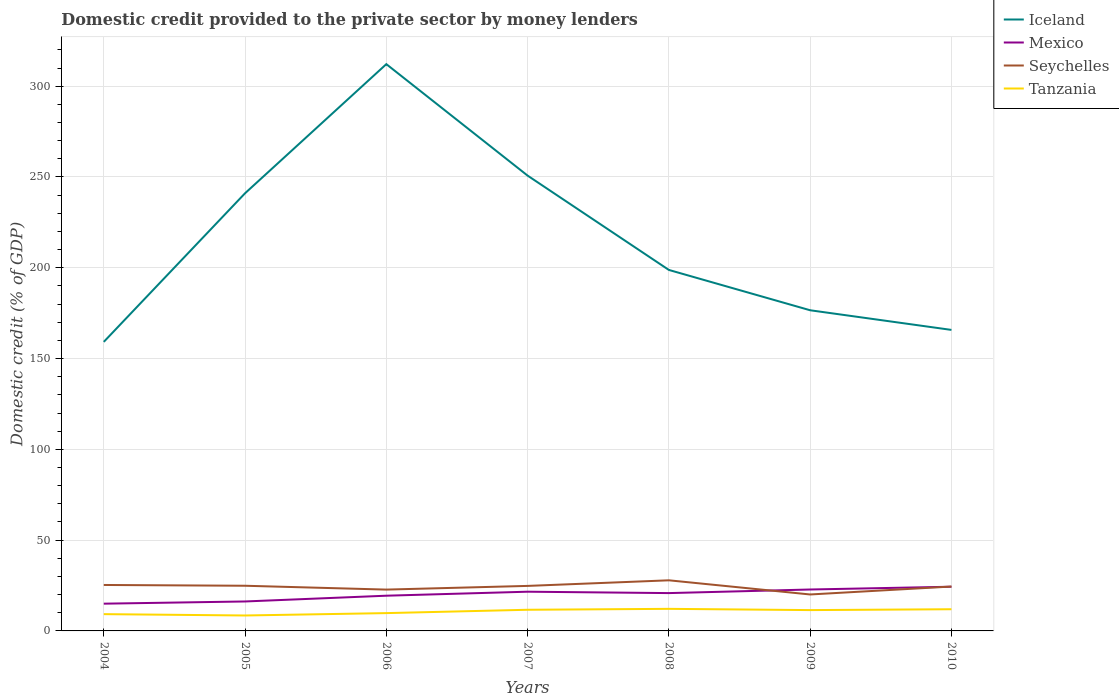How many different coloured lines are there?
Make the answer very short. 4. Is the number of lines equal to the number of legend labels?
Make the answer very short. Yes. Across all years, what is the maximum domestic credit provided to the private sector by money lenders in Tanzania?
Ensure brevity in your answer.  8.5. In which year was the domestic credit provided to the private sector by money lenders in Seychelles maximum?
Make the answer very short. 2009. What is the total domestic credit provided to the private sector by money lenders in Tanzania in the graph?
Your answer should be compact. -2.92. What is the difference between the highest and the second highest domestic credit provided to the private sector by money lenders in Tanzania?
Your answer should be very brief. 3.66. What is the difference between the highest and the lowest domestic credit provided to the private sector by money lenders in Iceland?
Your response must be concise. 3. Is the domestic credit provided to the private sector by money lenders in Iceland strictly greater than the domestic credit provided to the private sector by money lenders in Mexico over the years?
Make the answer very short. No. How many years are there in the graph?
Provide a short and direct response. 7. Are the values on the major ticks of Y-axis written in scientific E-notation?
Provide a succinct answer. No. Does the graph contain grids?
Provide a short and direct response. Yes. Where does the legend appear in the graph?
Provide a short and direct response. Top right. How many legend labels are there?
Make the answer very short. 4. What is the title of the graph?
Your answer should be very brief. Domestic credit provided to the private sector by money lenders. Does "Turkey" appear as one of the legend labels in the graph?
Ensure brevity in your answer.  No. What is the label or title of the X-axis?
Provide a short and direct response. Years. What is the label or title of the Y-axis?
Your answer should be compact. Domestic credit (% of GDP). What is the Domestic credit (% of GDP) in Iceland in 2004?
Provide a short and direct response. 159.19. What is the Domestic credit (% of GDP) of Mexico in 2004?
Make the answer very short. 15.01. What is the Domestic credit (% of GDP) in Seychelles in 2004?
Offer a terse response. 25.31. What is the Domestic credit (% of GDP) in Tanzania in 2004?
Give a very brief answer. 9.24. What is the Domestic credit (% of GDP) of Iceland in 2005?
Make the answer very short. 241.04. What is the Domestic credit (% of GDP) in Mexico in 2005?
Your response must be concise. 16.22. What is the Domestic credit (% of GDP) in Seychelles in 2005?
Make the answer very short. 24.88. What is the Domestic credit (% of GDP) of Tanzania in 2005?
Your response must be concise. 8.5. What is the Domestic credit (% of GDP) of Iceland in 2006?
Your answer should be very brief. 312.15. What is the Domestic credit (% of GDP) in Mexico in 2006?
Provide a succinct answer. 19.4. What is the Domestic credit (% of GDP) in Seychelles in 2006?
Offer a terse response. 22.76. What is the Domestic credit (% of GDP) of Tanzania in 2006?
Offer a very short reply. 9.81. What is the Domestic credit (% of GDP) of Iceland in 2007?
Ensure brevity in your answer.  250.76. What is the Domestic credit (% of GDP) in Mexico in 2007?
Give a very brief answer. 21.6. What is the Domestic credit (% of GDP) of Seychelles in 2007?
Provide a short and direct response. 24.79. What is the Domestic credit (% of GDP) of Tanzania in 2007?
Offer a very short reply. 11.65. What is the Domestic credit (% of GDP) in Iceland in 2008?
Offer a terse response. 198.81. What is the Domestic credit (% of GDP) of Mexico in 2008?
Ensure brevity in your answer.  20.84. What is the Domestic credit (% of GDP) in Seychelles in 2008?
Provide a succinct answer. 27.88. What is the Domestic credit (% of GDP) in Tanzania in 2008?
Offer a terse response. 12.16. What is the Domestic credit (% of GDP) of Iceland in 2009?
Ensure brevity in your answer.  176.6. What is the Domestic credit (% of GDP) in Mexico in 2009?
Ensure brevity in your answer.  22.81. What is the Domestic credit (% of GDP) in Seychelles in 2009?
Your answer should be compact. 20.07. What is the Domestic credit (% of GDP) in Tanzania in 2009?
Ensure brevity in your answer.  11.47. What is the Domestic credit (% of GDP) of Iceland in 2010?
Offer a terse response. 165.78. What is the Domestic credit (% of GDP) of Mexico in 2010?
Offer a very short reply. 24.34. What is the Domestic credit (% of GDP) in Seychelles in 2010?
Offer a terse response. 24.45. What is the Domestic credit (% of GDP) of Tanzania in 2010?
Provide a succinct answer. 11.94. Across all years, what is the maximum Domestic credit (% of GDP) of Iceland?
Keep it short and to the point. 312.15. Across all years, what is the maximum Domestic credit (% of GDP) of Mexico?
Your answer should be compact. 24.34. Across all years, what is the maximum Domestic credit (% of GDP) of Seychelles?
Your response must be concise. 27.88. Across all years, what is the maximum Domestic credit (% of GDP) of Tanzania?
Your answer should be very brief. 12.16. Across all years, what is the minimum Domestic credit (% of GDP) in Iceland?
Give a very brief answer. 159.19. Across all years, what is the minimum Domestic credit (% of GDP) in Mexico?
Provide a succinct answer. 15.01. Across all years, what is the minimum Domestic credit (% of GDP) of Seychelles?
Your response must be concise. 20.07. Across all years, what is the minimum Domestic credit (% of GDP) in Tanzania?
Your answer should be compact. 8.5. What is the total Domestic credit (% of GDP) in Iceland in the graph?
Your answer should be compact. 1504.34. What is the total Domestic credit (% of GDP) in Mexico in the graph?
Offer a very short reply. 140.21. What is the total Domestic credit (% of GDP) in Seychelles in the graph?
Make the answer very short. 170.14. What is the total Domestic credit (% of GDP) of Tanzania in the graph?
Offer a very short reply. 74.78. What is the difference between the Domestic credit (% of GDP) in Iceland in 2004 and that in 2005?
Provide a short and direct response. -81.85. What is the difference between the Domestic credit (% of GDP) in Mexico in 2004 and that in 2005?
Give a very brief answer. -1.21. What is the difference between the Domestic credit (% of GDP) in Seychelles in 2004 and that in 2005?
Provide a short and direct response. 0.43. What is the difference between the Domestic credit (% of GDP) in Tanzania in 2004 and that in 2005?
Your answer should be compact. 0.74. What is the difference between the Domestic credit (% of GDP) in Iceland in 2004 and that in 2006?
Make the answer very short. -152.96. What is the difference between the Domestic credit (% of GDP) of Mexico in 2004 and that in 2006?
Keep it short and to the point. -4.39. What is the difference between the Domestic credit (% of GDP) of Seychelles in 2004 and that in 2006?
Keep it short and to the point. 2.55. What is the difference between the Domestic credit (% of GDP) in Tanzania in 2004 and that in 2006?
Give a very brief answer. -0.57. What is the difference between the Domestic credit (% of GDP) of Iceland in 2004 and that in 2007?
Your answer should be very brief. -91.57. What is the difference between the Domestic credit (% of GDP) in Mexico in 2004 and that in 2007?
Your answer should be very brief. -6.59. What is the difference between the Domestic credit (% of GDP) of Seychelles in 2004 and that in 2007?
Offer a very short reply. 0.52. What is the difference between the Domestic credit (% of GDP) of Tanzania in 2004 and that in 2007?
Your answer should be compact. -2.41. What is the difference between the Domestic credit (% of GDP) of Iceland in 2004 and that in 2008?
Provide a short and direct response. -39.62. What is the difference between the Domestic credit (% of GDP) of Mexico in 2004 and that in 2008?
Give a very brief answer. -5.83. What is the difference between the Domestic credit (% of GDP) in Seychelles in 2004 and that in 2008?
Make the answer very short. -2.57. What is the difference between the Domestic credit (% of GDP) in Tanzania in 2004 and that in 2008?
Provide a succinct answer. -2.92. What is the difference between the Domestic credit (% of GDP) in Iceland in 2004 and that in 2009?
Offer a terse response. -17.41. What is the difference between the Domestic credit (% of GDP) in Mexico in 2004 and that in 2009?
Your answer should be very brief. -7.8. What is the difference between the Domestic credit (% of GDP) in Seychelles in 2004 and that in 2009?
Offer a terse response. 5.24. What is the difference between the Domestic credit (% of GDP) in Tanzania in 2004 and that in 2009?
Make the answer very short. -2.23. What is the difference between the Domestic credit (% of GDP) in Iceland in 2004 and that in 2010?
Your response must be concise. -6.59. What is the difference between the Domestic credit (% of GDP) in Mexico in 2004 and that in 2010?
Make the answer very short. -9.34. What is the difference between the Domestic credit (% of GDP) in Seychelles in 2004 and that in 2010?
Offer a very short reply. 0.87. What is the difference between the Domestic credit (% of GDP) of Tanzania in 2004 and that in 2010?
Give a very brief answer. -2.7. What is the difference between the Domestic credit (% of GDP) of Iceland in 2005 and that in 2006?
Give a very brief answer. -71.11. What is the difference between the Domestic credit (% of GDP) in Mexico in 2005 and that in 2006?
Give a very brief answer. -3.18. What is the difference between the Domestic credit (% of GDP) of Seychelles in 2005 and that in 2006?
Offer a very short reply. 2.11. What is the difference between the Domestic credit (% of GDP) of Tanzania in 2005 and that in 2006?
Keep it short and to the point. -1.31. What is the difference between the Domestic credit (% of GDP) of Iceland in 2005 and that in 2007?
Ensure brevity in your answer.  -9.72. What is the difference between the Domestic credit (% of GDP) in Mexico in 2005 and that in 2007?
Your answer should be very brief. -5.38. What is the difference between the Domestic credit (% of GDP) of Seychelles in 2005 and that in 2007?
Provide a succinct answer. 0.08. What is the difference between the Domestic credit (% of GDP) in Tanzania in 2005 and that in 2007?
Your answer should be compact. -3.15. What is the difference between the Domestic credit (% of GDP) in Iceland in 2005 and that in 2008?
Your answer should be compact. 42.24. What is the difference between the Domestic credit (% of GDP) in Mexico in 2005 and that in 2008?
Your answer should be very brief. -4.62. What is the difference between the Domestic credit (% of GDP) of Seychelles in 2005 and that in 2008?
Your answer should be very brief. -3. What is the difference between the Domestic credit (% of GDP) in Tanzania in 2005 and that in 2008?
Provide a succinct answer. -3.66. What is the difference between the Domestic credit (% of GDP) of Iceland in 2005 and that in 2009?
Keep it short and to the point. 64.44. What is the difference between the Domestic credit (% of GDP) in Mexico in 2005 and that in 2009?
Give a very brief answer. -6.59. What is the difference between the Domestic credit (% of GDP) in Seychelles in 2005 and that in 2009?
Keep it short and to the point. 4.8. What is the difference between the Domestic credit (% of GDP) in Tanzania in 2005 and that in 2009?
Offer a terse response. -2.96. What is the difference between the Domestic credit (% of GDP) of Iceland in 2005 and that in 2010?
Offer a terse response. 75.26. What is the difference between the Domestic credit (% of GDP) in Mexico in 2005 and that in 2010?
Give a very brief answer. -8.12. What is the difference between the Domestic credit (% of GDP) of Seychelles in 2005 and that in 2010?
Provide a succinct answer. 0.43. What is the difference between the Domestic credit (% of GDP) in Tanzania in 2005 and that in 2010?
Provide a succinct answer. -3.44. What is the difference between the Domestic credit (% of GDP) in Iceland in 2006 and that in 2007?
Provide a succinct answer. 61.39. What is the difference between the Domestic credit (% of GDP) of Mexico in 2006 and that in 2007?
Your answer should be very brief. -2.2. What is the difference between the Domestic credit (% of GDP) of Seychelles in 2006 and that in 2007?
Give a very brief answer. -2.03. What is the difference between the Domestic credit (% of GDP) in Tanzania in 2006 and that in 2007?
Provide a short and direct response. -1.84. What is the difference between the Domestic credit (% of GDP) of Iceland in 2006 and that in 2008?
Provide a short and direct response. 113.35. What is the difference between the Domestic credit (% of GDP) of Mexico in 2006 and that in 2008?
Make the answer very short. -1.44. What is the difference between the Domestic credit (% of GDP) in Seychelles in 2006 and that in 2008?
Keep it short and to the point. -5.11. What is the difference between the Domestic credit (% of GDP) of Tanzania in 2006 and that in 2008?
Offer a terse response. -2.35. What is the difference between the Domestic credit (% of GDP) of Iceland in 2006 and that in 2009?
Your answer should be very brief. 135.55. What is the difference between the Domestic credit (% of GDP) in Mexico in 2006 and that in 2009?
Provide a short and direct response. -3.41. What is the difference between the Domestic credit (% of GDP) of Seychelles in 2006 and that in 2009?
Make the answer very short. 2.69. What is the difference between the Domestic credit (% of GDP) in Tanzania in 2006 and that in 2009?
Offer a terse response. -1.66. What is the difference between the Domestic credit (% of GDP) of Iceland in 2006 and that in 2010?
Make the answer very short. 146.37. What is the difference between the Domestic credit (% of GDP) of Mexico in 2006 and that in 2010?
Give a very brief answer. -4.95. What is the difference between the Domestic credit (% of GDP) in Seychelles in 2006 and that in 2010?
Provide a succinct answer. -1.68. What is the difference between the Domestic credit (% of GDP) in Tanzania in 2006 and that in 2010?
Give a very brief answer. -2.13. What is the difference between the Domestic credit (% of GDP) in Iceland in 2007 and that in 2008?
Ensure brevity in your answer.  51.96. What is the difference between the Domestic credit (% of GDP) in Mexico in 2007 and that in 2008?
Make the answer very short. 0.76. What is the difference between the Domestic credit (% of GDP) in Seychelles in 2007 and that in 2008?
Provide a succinct answer. -3.08. What is the difference between the Domestic credit (% of GDP) in Tanzania in 2007 and that in 2008?
Your answer should be compact. -0.51. What is the difference between the Domestic credit (% of GDP) of Iceland in 2007 and that in 2009?
Offer a terse response. 74.16. What is the difference between the Domestic credit (% of GDP) of Mexico in 2007 and that in 2009?
Make the answer very short. -1.21. What is the difference between the Domestic credit (% of GDP) of Seychelles in 2007 and that in 2009?
Ensure brevity in your answer.  4.72. What is the difference between the Domestic credit (% of GDP) in Tanzania in 2007 and that in 2009?
Keep it short and to the point. 0.18. What is the difference between the Domestic credit (% of GDP) of Iceland in 2007 and that in 2010?
Give a very brief answer. 84.98. What is the difference between the Domestic credit (% of GDP) in Mexico in 2007 and that in 2010?
Offer a terse response. -2.74. What is the difference between the Domestic credit (% of GDP) of Seychelles in 2007 and that in 2010?
Offer a terse response. 0.35. What is the difference between the Domestic credit (% of GDP) of Tanzania in 2007 and that in 2010?
Keep it short and to the point. -0.29. What is the difference between the Domestic credit (% of GDP) in Iceland in 2008 and that in 2009?
Offer a very short reply. 22.2. What is the difference between the Domestic credit (% of GDP) in Mexico in 2008 and that in 2009?
Your answer should be compact. -1.97. What is the difference between the Domestic credit (% of GDP) of Seychelles in 2008 and that in 2009?
Offer a terse response. 7.8. What is the difference between the Domestic credit (% of GDP) in Tanzania in 2008 and that in 2009?
Provide a succinct answer. 0.69. What is the difference between the Domestic credit (% of GDP) of Iceland in 2008 and that in 2010?
Provide a short and direct response. 33.02. What is the difference between the Domestic credit (% of GDP) of Mexico in 2008 and that in 2010?
Offer a very short reply. -3.51. What is the difference between the Domestic credit (% of GDP) of Seychelles in 2008 and that in 2010?
Offer a very short reply. 3.43. What is the difference between the Domestic credit (% of GDP) in Tanzania in 2008 and that in 2010?
Your answer should be very brief. 0.22. What is the difference between the Domestic credit (% of GDP) of Iceland in 2009 and that in 2010?
Ensure brevity in your answer.  10.82. What is the difference between the Domestic credit (% of GDP) in Mexico in 2009 and that in 2010?
Provide a short and direct response. -1.53. What is the difference between the Domestic credit (% of GDP) in Seychelles in 2009 and that in 2010?
Offer a very short reply. -4.37. What is the difference between the Domestic credit (% of GDP) of Tanzania in 2009 and that in 2010?
Provide a succinct answer. -0.48. What is the difference between the Domestic credit (% of GDP) of Iceland in 2004 and the Domestic credit (% of GDP) of Mexico in 2005?
Your answer should be very brief. 142.97. What is the difference between the Domestic credit (% of GDP) of Iceland in 2004 and the Domestic credit (% of GDP) of Seychelles in 2005?
Provide a short and direct response. 134.31. What is the difference between the Domestic credit (% of GDP) of Iceland in 2004 and the Domestic credit (% of GDP) of Tanzania in 2005?
Make the answer very short. 150.69. What is the difference between the Domestic credit (% of GDP) of Mexico in 2004 and the Domestic credit (% of GDP) of Seychelles in 2005?
Your answer should be very brief. -9.87. What is the difference between the Domestic credit (% of GDP) in Mexico in 2004 and the Domestic credit (% of GDP) in Tanzania in 2005?
Offer a very short reply. 6.5. What is the difference between the Domestic credit (% of GDP) of Seychelles in 2004 and the Domestic credit (% of GDP) of Tanzania in 2005?
Offer a very short reply. 16.81. What is the difference between the Domestic credit (% of GDP) in Iceland in 2004 and the Domestic credit (% of GDP) in Mexico in 2006?
Give a very brief answer. 139.79. What is the difference between the Domestic credit (% of GDP) of Iceland in 2004 and the Domestic credit (% of GDP) of Seychelles in 2006?
Your answer should be compact. 136.42. What is the difference between the Domestic credit (% of GDP) in Iceland in 2004 and the Domestic credit (% of GDP) in Tanzania in 2006?
Give a very brief answer. 149.38. What is the difference between the Domestic credit (% of GDP) of Mexico in 2004 and the Domestic credit (% of GDP) of Seychelles in 2006?
Offer a very short reply. -7.76. What is the difference between the Domestic credit (% of GDP) of Mexico in 2004 and the Domestic credit (% of GDP) of Tanzania in 2006?
Your answer should be compact. 5.2. What is the difference between the Domestic credit (% of GDP) in Seychelles in 2004 and the Domestic credit (% of GDP) in Tanzania in 2006?
Ensure brevity in your answer.  15.5. What is the difference between the Domestic credit (% of GDP) of Iceland in 2004 and the Domestic credit (% of GDP) of Mexico in 2007?
Your answer should be compact. 137.59. What is the difference between the Domestic credit (% of GDP) of Iceland in 2004 and the Domestic credit (% of GDP) of Seychelles in 2007?
Offer a very short reply. 134.4. What is the difference between the Domestic credit (% of GDP) of Iceland in 2004 and the Domestic credit (% of GDP) of Tanzania in 2007?
Your response must be concise. 147.54. What is the difference between the Domestic credit (% of GDP) in Mexico in 2004 and the Domestic credit (% of GDP) in Seychelles in 2007?
Make the answer very short. -9.79. What is the difference between the Domestic credit (% of GDP) of Mexico in 2004 and the Domestic credit (% of GDP) of Tanzania in 2007?
Ensure brevity in your answer.  3.35. What is the difference between the Domestic credit (% of GDP) of Seychelles in 2004 and the Domestic credit (% of GDP) of Tanzania in 2007?
Make the answer very short. 13.66. What is the difference between the Domestic credit (% of GDP) in Iceland in 2004 and the Domestic credit (% of GDP) in Mexico in 2008?
Give a very brief answer. 138.35. What is the difference between the Domestic credit (% of GDP) in Iceland in 2004 and the Domestic credit (% of GDP) in Seychelles in 2008?
Your answer should be compact. 131.31. What is the difference between the Domestic credit (% of GDP) in Iceland in 2004 and the Domestic credit (% of GDP) in Tanzania in 2008?
Your answer should be very brief. 147.03. What is the difference between the Domestic credit (% of GDP) of Mexico in 2004 and the Domestic credit (% of GDP) of Seychelles in 2008?
Offer a very short reply. -12.87. What is the difference between the Domestic credit (% of GDP) of Mexico in 2004 and the Domestic credit (% of GDP) of Tanzania in 2008?
Give a very brief answer. 2.85. What is the difference between the Domestic credit (% of GDP) of Seychelles in 2004 and the Domestic credit (% of GDP) of Tanzania in 2008?
Your response must be concise. 13.15. What is the difference between the Domestic credit (% of GDP) in Iceland in 2004 and the Domestic credit (% of GDP) in Mexico in 2009?
Give a very brief answer. 136.38. What is the difference between the Domestic credit (% of GDP) of Iceland in 2004 and the Domestic credit (% of GDP) of Seychelles in 2009?
Provide a succinct answer. 139.12. What is the difference between the Domestic credit (% of GDP) in Iceland in 2004 and the Domestic credit (% of GDP) in Tanzania in 2009?
Keep it short and to the point. 147.72. What is the difference between the Domestic credit (% of GDP) in Mexico in 2004 and the Domestic credit (% of GDP) in Seychelles in 2009?
Offer a terse response. -5.07. What is the difference between the Domestic credit (% of GDP) in Mexico in 2004 and the Domestic credit (% of GDP) in Tanzania in 2009?
Offer a terse response. 3.54. What is the difference between the Domestic credit (% of GDP) in Seychelles in 2004 and the Domestic credit (% of GDP) in Tanzania in 2009?
Provide a succinct answer. 13.84. What is the difference between the Domestic credit (% of GDP) of Iceland in 2004 and the Domestic credit (% of GDP) of Mexico in 2010?
Your response must be concise. 134.85. What is the difference between the Domestic credit (% of GDP) in Iceland in 2004 and the Domestic credit (% of GDP) in Seychelles in 2010?
Make the answer very short. 134.74. What is the difference between the Domestic credit (% of GDP) in Iceland in 2004 and the Domestic credit (% of GDP) in Tanzania in 2010?
Your answer should be very brief. 147.25. What is the difference between the Domestic credit (% of GDP) of Mexico in 2004 and the Domestic credit (% of GDP) of Seychelles in 2010?
Provide a succinct answer. -9.44. What is the difference between the Domestic credit (% of GDP) of Mexico in 2004 and the Domestic credit (% of GDP) of Tanzania in 2010?
Your answer should be very brief. 3.06. What is the difference between the Domestic credit (% of GDP) of Seychelles in 2004 and the Domestic credit (% of GDP) of Tanzania in 2010?
Your response must be concise. 13.37. What is the difference between the Domestic credit (% of GDP) of Iceland in 2005 and the Domestic credit (% of GDP) of Mexico in 2006?
Provide a short and direct response. 221.65. What is the difference between the Domestic credit (% of GDP) of Iceland in 2005 and the Domestic credit (% of GDP) of Seychelles in 2006?
Offer a terse response. 218.28. What is the difference between the Domestic credit (% of GDP) of Iceland in 2005 and the Domestic credit (% of GDP) of Tanzania in 2006?
Offer a terse response. 231.23. What is the difference between the Domestic credit (% of GDP) in Mexico in 2005 and the Domestic credit (% of GDP) in Seychelles in 2006?
Offer a terse response. -6.55. What is the difference between the Domestic credit (% of GDP) in Mexico in 2005 and the Domestic credit (% of GDP) in Tanzania in 2006?
Your response must be concise. 6.41. What is the difference between the Domestic credit (% of GDP) of Seychelles in 2005 and the Domestic credit (% of GDP) of Tanzania in 2006?
Keep it short and to the point. 15.06. What is the difference between the Domestic credit (% of GDP) of Iceland in 2005 and the Domestic credit (% of GDP) of Mexico in 2007?
Your answer should be compact. 219.44. What is the difference between the Domestic credit (% of GDP) of Iceland in 2005 and the Domestic credit (% of GDP) of Seychelles in 2007?
Give a very brief answer. 216.25. What is the difference between the Domestic credit (% of GDP) of Iceland in 2005 and the Domestic credit (% of GDP) of Tanzania in 2007?
Ensure brevity in your answer.  229.39. What is the difference between the Domestic credit (% of GDP) in Mexico in 2005 and the Domestic credit (% of GDP) in Seychelles in 2007?
Offer a very short reply. -8.58. What is the difference between the Domestic credit (% of GDP) in Mexico in 2005 and the Domestic credit (% of GDP) in Tanzania in 2007?
Provide a short and direct response. 4.57. What is the difference between the Domestic credit (% of GDP) of Seychelles in 2005 and the Domestic credit (% of GDP) of Tanzania in 2007?
Your answer should be very brief. 13.22. What is the difference between the Domestic credit (% of GDP) in Iceland in 2005 and the Domestic credit (% of GDP) in Mexico in 2008?
Provide a short and direct response. 220.21. What is the difference between the Domestic credit (% of GDP) of Iceland in 2005 and the Domestic credit (% of GDP) of Seychelles in 2008?
Give a very brief answer. 213.17. What is the difference between the Domestic credit (% of GDP) in Iceland in 2005 and the Domestic credit (% of GDP) in Tanzania in 2008?
Make the answer very short. 228.88. What is the difference between the Domestic credit (% of GDP) of Mexico in 2005 and the Domestic credit (% of GDP) of Seychelles in 2008?
Provide a succinct answer. -11.66. What is the difference between the Domestic credit (% of GDP) of Mexico in 2005 and the Domestic credit (% of GDP) of Tanzania in 2008?
Give a very brief answer. 4.06. What is the difference between the Domestic credit (% of GDP) in Seychelles in 2005 and the Domestic credit (% of GDP) in Tanzania in 2008?
Your response must be concise. 12.72. What is the difference between the Domestic credit (% of GDP) of Iceland in 2005 and the Domestic credit (% of GDP) of Mexico in 2009?
Your answer should be compact. 218.23. What is the difference between the Domestic credit (% of GDP) of Iceland in 2005 and the Domestic credit (% of GDP) of Seychelles in 2009?
Make the answer very short. 220.97. What is the difference between the Domestic credit (% of GDP) of Iceland in 2005 and the Domestic credit (% of GDP) of Tanzania in 2009?
Provide a short and direct response. 229.58. What is the difference between the Domestic credit (% of GDP) in Mexico in 2005 and the Domestic credit (% of GDP) in Seychelles in 2009?
Your answer should be compact. -3.85. What is the difference between the Domestic credit (% of GDP) of Mexico in 2005 and the Domestic credit (% of GDP) of Tanzania in 2009?
Ensure brevity in your answer.  4.75. What is the difference between the Domestic credit (% of GDP) of Seychelles in 2005 and the Domestic credit (% of GDP) of Tanzania in 2009?
Provide a succinct answer. 13.41. What is the difference between the Domestic credit (% of GDP) in Iceland in 2005 and the Domestic credit (% of GDP) in Mexico in 2010?
Ensure brevity in your answer.  216.7. What is the difference between the Domestic credit (% of GDP) of Iceland in 2005 and the Domestic credit (% of GDP) of Seychelles in 2010?
Provide a short and direct response. 216.6. What is the difference between the Domestic credit (% of GDP) of Iceland in 2005 and the Domestic credit (% of GDP) of Tanzania in 2010?
Make the answer very short. 229.1. What is the difference between the Domestic credit (% of GDP) in Mexico in 2005 and the Domestic credit (% of GDP) in Seychelles in 2010?
Provide a short and direct response. -8.23. What is the difference between the Domestic credit (% of GDP) of Mexico in 2005 and the Domestic credit (% of GDP) of Tanzania in 2010?
Keep it short and to the point. 4.28. What is the difference between the Domestic credit (% of GDP) of Seychelles in 2005 and the Domestic credit (% of GDP) of Tanzania in 2010?
Give a very brief answer. 12.93. What is the difference between the Domestic credit (% of GDP) of Iceland in 2006 and the Domestic credit (% of GDP) of Mexico in 2007?
Offer a very short reply. 290.55. What is the difference between the Domestic credit (% of GDP) of Iceland in 2006 and the Domestic credit (% of GDP) of Seychelles in 2007?
Your response must be concise. 287.36. What is the difference between the Domestic credit (% of GDP) in Iceland in 2006 and the Domestic credit (% of GDP) in Tanzania in 2007?
Your response must be concise. 300.5. What is the difference between the Domestic credit (% of GDP) of Mexico in 2006 and the Domestic credit (% of GDP) of Seychelles in 2007?
Keep it short and to the point. -5.4. What is the difference between the Domestic credit (% of GDP) in Mexico in 2006 and the Domestic credit (% of GDP) in Tanzania in 2007?
Provide a succinct answer. 7.75. What is the difference between the Domestic credit (% of GDP) of Seychelles in 2006 and the Domestic credit (% of GDP) of Tanzania in 2007?
Offer a terse response. 11.11. What is the difference between the Domestic credit (% of GDP) of Iceland in 2006 and the Domestic credit (% of GDP) of Mexico in 2008?
Give a very brief answer. 291.32. What is the difference between the Domestic credit (% of GDP) in Iceland in 2006 and the Domestic credit (% of GDP) in Seychelles in 2008?
Make the answer very short. 284.28. What is the difference between the Domestic credit (% of GDP) of Iceland in 2006 and the Domestic credit (% of GDP) of Tanzania in 2008?
Offer a very short reply. 299.99. What is the difference between the Domestic credit (% of GDP) in Mexico in 2006 and the Domestic credit (% of GDP) in Seychelles in 2008?
Your answer should be very brief. -8.48. What is the difference between the Domestic credit (% of GDP) of Mexico in 2006 and the Domestic credit (% of GDP) of Tanzania in 2008?
Ensure brevity in your answer.  7.24. What is the difference between the Domestic credit (% of GDP) in Seychelles in 2006 and the Domestic credit (% of GDP) in Tanzania in 2008?
Your answer should be compact. 10.6. What is the difference between the Domestic credit (% of GDP) of Iceland in 2006 and the Domestic credit (% of GDP) of Mexico in 2009?
Make the answer very short. 289.34. What is the difference between the Domestic credit (% of GDP) of Iceland in 2006 and the Domestic credit (% of GDP) of Seychelles in 2009?
Your answer should be compact. 292.08. What is the difference between the Domestic credit (% of GDP) of Iceland in 2006 and the Domestic credit (% of GDP) of Tanzania in 2009?
Offer a very short reply. 300.69. What is the difference between the Domestic credit (% of GDP) in Mexico in 2006 and the Domestic credit (% of GDP) in Seychelles in 2009?
Your answer should be very brief. -0.68. What is the difference between the Domestic credit (% of GDP) of Mexico in 2006 and the Domestic credit (% of GDP) of Tanzania in 2009?
Provide a short and direct response. 7.93. What is the difference between the Domestic credit (% of GDP) of Seychelles in 2006 and the Domestic credit (% of GDP) of Tanzania in 2009?
Ensure brevity in your answer.  11.3. What is the difference between the Domestic credit (% of GDP) of Iceland in 2006 and the Domestic credit (% of GDP) of Mexico in 2010?
Your answer should be compact. 287.81. What is the difference between the Domestic credit (% of GDP) in Iceland in 2006 and the Domestic credit (% of GDP) in Seychelles in 2010?
Provide a succinct answer. 287.71. What is the difference between the Domestic credit (% of GDP) of Iceland in 2006 and the Domestic credit (% of GDP) of Tanzania in 2010?
Offer a very short reply. 300.21. What is the difference between the Domestic credit (% of GDP) in Mexico in 2006 and the Domestic credit (% of GDP) in Seychelles in 2010?
Provide a succinct answer. -5.05. What is the difference between the Domestic credit (% of GDP) of Mexico in 2006 and the Domestic credit (% of GDP) of Tanzania in 2010?
Give a very brief answer. 7.45. What is the difference between the Domestic credit (% of GDP) in Seychelles in 2006 and the Domestic credit (% of GDP) in Tanzania in 2010?
Your response must be concise. 10.82. What is the difference between the Domestic credit (% of GDP) of Iceland in 2007 and the Domestic credit (% of GDP) of Mexico in 2008?
Your answer should be very brief. 229.93. What is the difference between the Domestic credit (% of GDP) in Iceland in 2007 and the Domestic credit (% of GDP) in Seychelles in 2008?
Offer a very short reply. 222.89. What is the difference between the Domestic credit (% of GDP) of Iceland in 2007 and the Domestic credit (% of GDP) of Tanzania in 2008?
Keep it short and to the point. 238.6. What is the difference between the Domestic credit (% of GDP) in Mexico in 2007 and the Domestic credit (% of GDP) in Seychelles in 2008?
Give a very brief answer. -6.28. What is the difference between the Domestic credit (% of GDP) in Mexico in 2007 and the Domestic credit (% of GDP) in Tanzania in 2008?
Make the answer very short. 9.44. What is the difference between the Domestic credit (% of GDP) of Seychelles in 2007 and the Domestic credit (% of GDP) of Tanzania in 2008?
Give a very brief answer. 12.63. What is the difference between the Domestic credit (% of GDP) of Iceland in 2007 and the Domestic credit (% of GDP) of Mexico in 2009?
Give a very brief answer. 227.95. What is the difference between the Domestic credit (% of GDP) of Iceland in 2007 and the Domestic credit (% of GDP) of Seychelles in 2009?
Your answer should be compact. 230.69. What is the difference between the Domestic credit (% of GDP) in Iceland in 2007 and the Domestic credit (% of GDP) in Tanzania in 2009?
Your answer should be very brief. 239.3. What is the difference between the Domestic credit (% of GDP) in Mexico in 2007 and the Domestic credit (% of GDP) in Seychelles in 2009?
Your response must be concise. 1.53. What is the difference between the Domestic credit (% of GDP) in Mexico in 2007 and the Domestic credit (% of GDP) in Tanzania in 2009?
Keep it short and to the point. 10.13. What is the difference between the Domestic credit (% of GDP) in Seychelles in 2007 and the Domestic credit (% of GDP) in Tanzania in 2009?
Keep it short and to the point. 13.33. What is the difference between the Domestic credit (% of GDP) of Iceland in 2007 and the Domestic credit (% of GDP) of Mexico in 2010?
Ensure brevity in your answer.  226.42. What is the difference between the Domestic credit (% of GDP) in Iceland in 2007 and the Domestic credit (% of GDP) in Seychelles in 2010?
Your answer should be very brief. 226.32. What is the difference between the Domestic credit (% of GDP) of Iceland in 2007 and the Domestic credit (% of GDP) of Tanzania in 2010?
Your answer should be compact. 238.82. What is the difference between the Domestic credit (% of GDP) in Mexico in 2007 and the Domestic credit (% of GDP) in Seychelles in 2010?
Ensure brevity in your answer.  -2.85. What is the difference between the Domestic credit (% of GDP) in Mexico in 2007 and the Domestic credit (% of GDP) in Tanzania in 2010?
Your response must be concise. 9.66. What is the difference between the Domestic credit (% of GDP) in Seychelles in 2007 and the Domestic credit (% of GDP) in Tanzania in 2010?
Your response must be concise. 12.85. What is the difference between the Domestic credit (% of GDP) of Iceland in 2008 and the Domestic credit (% of GDP) of Mexico in 2009?
Provide a short and direct response. 176. What is the difference between the Domestic credit (% of GDP) in Iceland in 2008 and the Domestic credit (% of GDP) in Seychelles in 2009?
Your response must be concise. 178.73. What is the difference between the Domestic credit (% of GDP) of Iceland in 2008 and the Domestic credit (% of GDP) of Tanzania in 2009?
Offer a terse response. 187.34. What is the difference between the Domestic credit (% of GDP) in Mexico in 2008 and the Domestic credit (% of GDP) in Seychelles in 2009?
Your answer should be very brief. 0.76. What is the difference between the Domestic credit (% of GDP) in Mexico in 2008 and the Domestic credit (% of GDP) in Tanzania in 2009?
Make the answer very short. 9.37. What is the difference between the Domestic credit (% of GDP) of Seychelles in 2008 and the Domestic credit (% of GDP) of Tanzania in 2009?
Your answer should be compact. 16.41. What is the difference between the Domestic credit (% of GDP) in Iceland in 2008 and the Domestic credit (% of GDP) in Mexico in 2010?
Your answer should be very brief. 174.46. What is the difference between the Domestic credit (% of GDP) in Iceland in 2008 and the Domestic credit (% of GDP) in Seychelles in 2010?
Offer a terse response. 174.36. What is the difference between the Domestic credit (% of GDP) in Iceland in 2008 and the Domestic credit (% of GDP) in Tanzania in 2010?
Offer a very short reply. 186.86. What is the difference between the Domestic credit (% of GDP) in Mexico in 2008 and the Domestic credit (% of GDP) in Seychelles in 2010?
Your answer should be compact. -3.61. What is the difference between the Domestic credit (% of GDP) of Mexico in 2008 and the Domestic credit (% of GDP) of Tanzania in 2010?
Provide a succinct answer. 8.89. What is the difference between the Domestic credit (% of GDP) of Seychelles in 2008 and the Domestic credit (% of GDP) of Tanzania in 2010?
Make the answer very short. 15.93. What is the difference between the Domestic credit (% of GDP) in Iceland in 2009 and the Domestic credit (% of GDP) in Mexico in 2010?
Your response must be concise. 152.26. What is the difference between the Domestic credit (% of GDP) in Iceland in 2009 and the Domestic credit (% of GDP) in Seychelles in 2010?
Your response must be concise. 152.16. What is the difference between the Domestic credit (% of GDP) of Iceland in 2009 and the Domestic credit (% of GDP) of Tanzania in 2010?
Your answer should be very brief. 164.66. What is the difference between the Domestic credit (% of GDP) of Mexico in 2009 and the Domestic credit (% of GDP) of Seychelles in 2010?
Offer a terse response. -1.63. What is the difference between the Domestic credit (% of GDP) of Mexico in 2009 and the Domestic credit (% of GDP) of Tanzania in 2010?
Make the answer very short. 10.87. What is the difference between the Domestic credit (% of GDP) of Seychelles in 2009 and the Domestic credit (% of GDP) of Tanzania in 2010?
Provide a short and direct response. 8.13. What is the average Domestic credit (% of GDP) of Iceland per year?
Your response must be concise. 214.91. What is the average Domestic credit (% of GDP) in Mexico per year?
Give a very brief answer. 20.03. What is the average Domestic credit (% of GDP) in Seychelles per year?
Provide a short and direct response. 24.31. What is the average Domestic credit (% of GDP) of Tanzania per year?
Your answer should be very brief. 10.68. In the year 2004, what is the difference between the Domestic credit (% of GDP) of Iceland and Domestic credit (% of GDP) of Mexico?
Make the answer very short. 144.18. In the year 2004, what is the difference between the Domestic credit (% of GDP) of Iceland and Domestic credit (% of GDP) of Seychelles?
Offer a very short reply. 133.88. In the year 2004, what is the difference between the Domestic credit (% of GDP) in Iceland and Domestic credit (% of GDP) in Tanzania?
Give a very brief answer. 149.95. In the year 2004, what is the difference between the Domestic credit (% of GDP) in Mexico and Domestic credit (% of GDP) in Seychelles?
Your answer should be very brief. -10.3. In the year 2004, what is the difference between the Domestic credit (% of GDP) in Mexico and Domestic credit (% of GDP) in Tanzania?
Provide a succinct answer. 5.77. In the year 2004, what is the difference between the Domestic credit (% of GDP) in Seychelles and Domestic credit (% of GDP) in Tanzania?
Provide a short and direct response. 16.07. In the year 2005, what is the difference between the Domestic credit (% of GDP) in Iceland and Domestic credit (% of GDP) in Mexico?
Provide a short and direct response. 224.83. In the year 2005, what is the difference between the Domestic credit (% of GDP) in Iceland and Domestic credit (% of GDP) in Seychelles?
Make the answer very short. 216.17. In the year 2005, what is the difference between the Domestic credit (% of GDP) of Iceland and Domestic credit (% of GDP) of Tanzania?
Your response must be concise. 232.54. In the year 2005, what is the difference between the Domestic credit (% of GDP) of Mexico and Domestic credit (% of GDP) of Seychelles?
Provide a short and direct response. -8.66. In the year 2005, what is the difference between the Domestic credit (% of GDP) in Mexico and Domestic credit (% of GDP) in Tanzania?
Your answer should be very brief. 7.71. In the year 2005, what is the difference between the Domestic credit (% of GDP) in Seychelles and Domestic credit (% of GDP) in Tanzania?
Your answer should be compact. 16.37. In the year 2006, what is the difference between the Domestic credit (% of GDP) of Iceland and Domestic credit (% of GDP) of Mexico?
Keep it short and to the point. 292.76. In the year 2006, what is the difference between the Domestic credit (% of GDP) in Iceland and Domestic credit (% of GDP) in Seychelles?
Provide a short and direct response. 289.39. In the year 2006, what is the difference between the Domestic credit (% of GDP) of Iceland and Domestic credit (% of GDP) of Tanzania?
Provide a succinct answer. 302.34. In the year 2006, what is the difference between the Domestic credit (% of GDP) of Mexico and Domestic credit (% of GDP) of Seychelles?
Offer a very short reply. -3.37. In the year 2006, what is the difference between the Domestic credit (% of GDP) of Mexico and Domestic credit (% of GDP) of Tanzania?
Make the answer very short. 9.59. In the year 2006, what is the difference between the Domestic credit (% of GDP) in Seychelles and Domestic credit (% of GDP) in Tanzania?
Offer a terse response. 12.95. In the year 2007, what is the difference between the Domestic credit (% of GDP) of Iceland and Domestic credit (% of GDP) of Mexico?
Provide a short and direct response. 229.16. In the year 2007, what is the difference between the Domestic credit (% of GDP) in Iceland and Domestic credit (% of GDP) in Seychelles?
Ensure brevity in your answer.  225.97. In the year 2007, what is the difference between the Domestic credit (% of GDP) in Iceland and Domestic credit (% of GDP) in Tanzania?
Make the answer very short. 239.11. In the year 2007, what is the difference between the Domestic credit (% of GDP) in Mexico and Domestic credit (% of GDP) in Seychelles?
Offer a very short reply. -3.19. In the year 2007, what is the difference between the Domestic credit (% of GDP) of Mexico and Domestic credit (% of GDP) of Tanzania?
Keep it short and to the point. 9.95. In the year 2007, what is the difference between the Domestic credit (% of GDP) in Seychelles and Domestic credit (% of GDP) in Tanzania?
Keep it short and to the point. 13.14. In the year 2008, what is the difference between the Domestic credit (% of GDP) in Iceland and Domestic credit (% of GDP) in Mexico?
Provide a short and direct response. 177.97. In the year 2008, what is the difference between the Domestic credit (% of GDP) of Iceland and Domestic credit (% of GDP) of Seychelles?
Your answer should be compact. 170.93. In the year 2008, what is the difference between the Domestic credit (% of GDP) in Iceland and Domestic credit (% of GDP) in Tanzania?
Ensure brevity in your answer.  186.65. In the year 2008, what is the difference between the Domestic credit (% of GDP) of Mexico and Domestic credit (% of GDP) of Seychelles?
Ensure brevity in your answer.  -7.04. In the year 2008, what is the difference between the Domestic credit (% of GDP) of Mexico and Domestic credit (% of GDP) of Tanzania?
Provide a succinct answer. 8.68. In the year 2008, what is the difference between the Domestic credit (% of GDP) in Seychelles and Domestic credit (% of GDP) in Tanzania?
Ensure brevity in your answer.  15.72. In the year 2009, what is the difference between the Domestic credit (% of GDP) of Iceland and Domestic credit (% of GDP) of Mexico?
Offer a very short reply. 153.79. In the year 2009, what is the difference between the Domestic credit (% of GDP) in Iceland and Domestic credit (% of GDP) in Seychelles?
Provide a short and direct response. 156.53. In the year 2009, what is the difference between the Domestic credit (% of GDP) of Iceland and Domestic credit (% of GDP) of Tanzania?
Your response must be concise. 165.13. In the year 2009, what is the difference between the Domestic credit (% of GDP) of Mexico and Domestic credit (% of GDP) of Seychelles?
Make the answer very short. 2.74. In the year 2009, what is the difference between the Domestic credit (% of GDP) in Mexico and Domestic credit (% of GDP) in Tanzania?
Offer a very short reply. 11.34. In the year 2009, what is the difference between the Domestic credit (% of GDP) in Seychelles and Domestic credit (% of GDP) in Tanzania?
Provide a succinct answer. 8.61. In the year 2010, what is the difference between the Domestic credit (% of GDP) of Iceland and Domestic credit (% of GDP) of Mexico?
Ensure brevity in your answer.  141.44. In the year 2010, what is the difference between the Domestic credit (% of GDP) of Iceland and Domestic credit (% of GDP) of Seychelles?
Make the answer very short. 141.34. In the year 2010, what is the difference between the Domestic credit (% of GDP) in Iceland and Domestic credit (% of GDP) in Tanzania?
Provide a succinct answer. 153.84. In the year 2010, what is the difference between the Domestic credit (% of GDP) of Mexico and Domestic credit (% of GDP) of Seychelles?
Provide a short and direct response. -0.1. In the year 2010, what is the difference between the Domestic credit (% of GDP) in Mexico and Domestic credit (% of GDP) in Tanzania?
Make the answer very short. 12.4. In the year 2010, what is the difference between the Domestic credit (% of GDP) in Seychelles and Domestic credit (% of GDP) in Tanzania?
Your answer should be compact. 12.5. What is the ratio of the Domestic credit (% of GDP) of Iceland in 2004 to that in 2005?
Your answer should be very brief. 0.66. What is the ratio of the Domestic credit (% of GDP) in Mexico in 2004 to that in 2005?
Your response must be concise. 0.93. What is the ratio of the Domestic credit (% of GDP) of Seychelles in 2004 to that in 2005?
Provide a short and direct response. 1.02. What is the ratio of the Domestic credit (% of GDP) in Tanzania in 2004 to that in 2005?
Provide a short and direct response. 1.09. What is the ratio of the Domestic credit (% of GDP) of Iceland in 2004 to that in 2006?
Your response must be concise. 0.51. What is the ratio of the Domestic credit (% of GDP) of Mexico in 2004 to that in 2006?
Provide a succinct answer. 0.77. What is the ratio of the Domestic credit (% of GDP) of Seychelles in 2004 to that in 2006?
Provide a short and direct response. 1.11. What is the ratio of the Domestic credit (% of GDP) in Tanzania in 2004 to that in 2006?
Your answer should be very brief. 0.94. What is the ratio of the Domestic credit (% of GDP) in Iceland in 2004 to that in 2007?
Provide a short and direct response. 0.63. What is the ratio of the Domestic credit (% of GDP) of Mexico in 2004 to that in 2007?
Offer a terse response. 0.69. What is the ratio of the Domestic credit (% of GDP) of Seychelles in 2004 to that in 2007?
Give a very brief answer. 1.02. What is the ratio of the Domestic credit (% of GDP) in Tanzania in 2004 to that in 2007?
Your response must be concise. 0.79. What is the ratio of the Domestic credit (% of GDP) of Iceland in 2004 to that in 2008?
Ensure brevity in your answer.  0.8. What is the ratio of the Domestic credit (% of GDP) of Mexico in 2004 to that in 2008?
Offer a terse response. 0.72. What is the ratio of the Domestic credit (% of GDP) of Seychelles in 2004 to that in 2008?
Your response must be concise. 0.91. What is the ratio of the Domestic credit (% of GDP) of Tanzania in 2004 to that in 2008?
Your response must be concise. 0.76. What is the ratio of the Domestic credit (% of GDP) in Iceland in 2004 to that in 2009?
Provide a short and direct response. 0.9. What is the ratio of the Domestic credit (% of GDP) of Mexico in 2004 to that in 2009?
Your answer should be compact. 0.66. What is the ratio of the Domestic credit (% of GDP) in Seychelles in 2004 to that in 2009?
Your answer should be compact. 1.26. What is the ratio of the Domestic credit (% of GDP) in Tanzania in 2004 to that in 2009?
Keep it short and to the point. 0.81. What is the ratio of the Domestic credit (% of GDP) in Iceland in 2004 to that in 2010?
Ensure brevity in your answer.  0.96. What is the ratio of the Domestic credit (% of GDP) of Mexico in 2004 to that in 2010?
Offer a very short reply. 0.62. What is the ratio of the Domestic credit (% of GDP) in Seychelles in 2004 to that in 2010?
Make the answer very short. 1.04. What is the ratio of the Domestic credit (% of GDP) in Tanzania in 2004 to that in 2010?
Your response must be concise. 0.77. What is the ratio of the Domestic credit (% of GDP) in Iceland in 2005 to that in 2006?
Your answer should be very brief. 0.77. What is the ratio of the Domestic credit (% of GDP) of Mexico in 2005 to that in 2006?
Ensure brevity in your answer.  0.84. What is the ratio of the Domestic credit (% of GDP) in Seychelles in 2005 to that in 2006?
Offer a terse response. 1.09. What is the ratio of the Domestic credit (% of GDP) of Tanzania in 2005 to that in 2006?
Offer a very short reply. 0.87. What is the ratio of the Domestic credit (% of GDP) of Iceland in 2005 to that in 2007?
Offer a terse response. 0.96. What is the ratio of the Domestic credit (% of GDP) of Mexico in 2005 to that in 2007?
Offer a terse response. 0.75. What is the ratio of the Domestic credit (% of GDP) of Tanzania in 2005 to that in 2007?
Make the answer very short. 0.73. What is the ratio of the Domestic credit (% of GDP) of Iceland in 2005 to that in 2008?
Your answer should be very brief. 1.21. What is the ratio of the Domestic credit (% of GDP) of Mexico in 2005 to that in 2008?
Your answer should be very brief. 0.78. What is the ratio of the Domestic credit (% of GDP) in Seychelles in 2005 to that in 2008?
Your answer should be very brief. 0.89. What is the ratio of the Domestic credit (% of GDP) in Tanzania in 2005 to that in 2008?
Provide a short and direct response. 0.7. What is the ratio of the Domestic credit (% of GDP) in Iceland in 2005 to that in 2009?
Ensure brevity in your answer.  1.36. What is the ratio of the Domestic credit (% of GDP) in Mexico in 2005 to that in 2009?
Offer a very short reply. 0.71. What is the ratio of the Domestic credit (% of GDP) in Seychelles in 2005 to that in 2009?
Offer a terse response. 1.24. What is the ratio of the Domestic credit (% of GDP) in Tanzania in 2005 to that in 2009?
Keep it short and to the point. 0.74. What is the ratio of the Domestic credit (% of GDP) of Iceland in 2005 to that in 2010?
Offer a very short reply. 1.45. What is the ratio of the Domestic credit (% of GDP) of Mexico in 2005 to that in 2010?
Your answer should be compact. 0.67. What is the ratio of the Domestic credit (% of GDP) in Seychelles in 2005 to that in 2010?
Make the answer very short. 1.02. What is the ratio of the Domestic credit (% of GDP) in Tanzania in 2005 to that in 2010?
Your answer should be very brief. 0.71. What is the ratio of the Domestic credit (% of GDP) in Iceland in 2006 to that in 2007?
Provide a short and direct response. 1.24. What is the ratio of the Domestic credit (% of GDP) of Mexico in 2006 to that in 2007?
Your answer should be very brief. 0.9. What is the ratio of the Domestic credit (% of GDP) in Seychelles in 2006 to that in 2007?
Keep it short and to the point. 0.92. What is the ratio of the Domestic credit (% of GDP) in Tanzania in 2006 to that in 2007?
Offer a terse response. 0.84. What is the ratio of the Domestic credit (% of GDP) in Iceland in 2006 to that in 2008?
Provide a short and direct response. 1.57. What is the ratio of the Domestic credit (% of GDP) of Mexico in 2006 to that in 2008?
Your response must be concise. 0.93. What is the ratio of the Domestic credit (% of GDP) in Seychelles in 2006 to that in 2008?
Provide a succinct answer. 0.82. What is the ratio of the Domestic credit (% of GDP) in Tanzania in 2006 to that in 2008?
Give a very brief answer. 0.81. What is the ratio of the Domestic credit (% of GDP) of Iceland in 2006 to that in 2009?
Offer a terse response. 1.77. What is the ratio of the Domestic credit (% of GDP) in Mexico in 2006 to that in 2009?
Your answer should be compact. 0.85. What is the ratio of the Domestic credit (% of GDP) in Seychelles in 2006 to that in 2009?
Make the answer very short. 1.13. What is the ratio of the Domestic credit (% of GDP) of Tanzania in 2006 to that in 2009?
Your answer should be compact. 0.86. What is the ratio of the Domestic credit (% of GDP) of Iceland in 2006 to that in 2010?
Make the answer very short. 1.88. What is the ratio of the Domestic credit (% of GDP) in Mexico in 2006 to that in 2010?
Offer a very short reply. 0.8. What is the ratio of the Domestic credit (% of GDP) in Seychelles in 2006 to that in 2010?
Give a very brief answer. 0.93. What is the ratio of the Domestic credit (% of GDP) in Tanzania in 2006 to that in 2010?
Ensure brevity in your answer.  0.82. What is the ratio of the Domestic credit (% of GDP) of Iceland in 2007 to that in 2008?
Make the answer very short. 1.26. What is the ratio of the Domestic credit (% of GDP) in Mexico in 2007 to that in 2008?
Make the answer very short. 1.04. What is the ratio of the Domestic credit (% of GDP) in Seychelles in 2007 to that in 2008?
Give a very brief answer. 0.89. What is the ratio of the Domestic credit (% of GDP) in Tanzania in 2007 to that in 2008?
Offer a very short reply. 0.96. What is the ratio of the Domestic credit (% of GDP) of Iceland in 2007 to that in 2009?
Your answer should be very brief. 1.42. What is the ratio of the Domestic credit (% of GDP) in Mexico in 2007 to that in 2009?
Provide a succinct answer. 0.95. What is the ratio of the Domestic credit (% of GDP) of Seychelles in 2007 to that in 2009?
Keep it short and to the point. 1.24. What is the ratio of the Domestic credit (% of GDP) of Tanzania in 2007 to that in 2009?
Your answer should be compact. 1.02. What is the ratio of the Domestic credit (% of GDP) in Iceland in 2007 to that in 2010?
Your response must be concise. 1.51. What is the ratio of the Domestic credit (% of GDP) in Mexico in 2007 to that in 2010?
Ensure brevity in your answer.  0.89. What is the ratio of the Domestic credit (% of GDP) in Seychelles in 2007 to that in 2010?
Offer a very short reply. 1.01. What is the ratio of the Domestic credit (% of GDP) in Tanzania in 2007 to that in 2010?
Offer a very short reply. 0.98. What is the ratio of the Domestic credit (% of GDP) of Iceland in 2008 to that in 2009?
Keep it short and to the point. 1.13. What is the ratio of the Domestic credit (% of GDP) in Mexico in 2008 to that in 2009?
Ensure brevity in your answer.  0.91. What is the ratio of the Domestic credit (% of GDP) in Seychelles in 2008 to that in 2009?
Offer a terse response. 1.39. What is the ratio of the Domestic credit (% of GDP) of Tanzania in 2008 to that in 2009?
Keep it short and to the point. 1.06. What is the ratio of the Domestic credit (% of GDP) in Iceland in 2008 to that in 2010?
Your answer should be compact. 1.2. What is the ratio of the Domestic credit (% of GDP) in Mexico in 2008 to that in 2010?
Give a very brief answer. 0.86. What is the ratio of the Domestic credit (% of GDP) in Seychelles in 2008 to that in 2010?
Your answer should be compact. 1.14. What is the ratio of the Domestic credit (% of GDP) of Tanzania in 2008 to that in 2010?
Provide a short and direct response. 1.02. What is the ratio of the Domestic credit (% of GDP) in Iceland in 2009 to that in 2010?
Make the answer very short. 1.07. What is the ratio of the Domestic credit (% of GDP) in Mexico in 2009 to that in 2010?
Your answer should be compact. 0.94. What is the ratio of the Domestic credit (% of GDP) in Seychelles in 2009 to that in 2010?
Provide a succinct answer. 0.82. What is the ratio of the Domestic credit (% of GDP) of Tanzania in 2009 to that in 2010?
Ensure brevity in your answer.  0.96. What is the difference between the highest and the second highest Domestic credit (% of GDP) of Iceland?
Keep it short and to the point. 61.39. What is the difference between the highest and the second highest Domestic credit (% of GDP) of Mexico?
Your answer should be very brief. 1.53. What is the difference between the highest and the second highest Domestic credit (% of GDP) of Seychelles?
Your response must be concise. 2.57. What is the difference between the highest and the second highest Domestic credit (% of GDP) in Tanzania?
Offer a very short reply. 0.22. What is the difference between the highest and the lowest Domestic credit (% of GDP) in Iceland?
Your response must be concise. 152.96. What is the difference between the highest and the lowest Domestic credit (% of GDP) in Mexico?
Ensure brevity in your answer.  9.34. What is the difference between the highest and the lowest Domestic credit (% of GDP) in Seychelles?
Your answer should be compact. 7.8. What is the difference between the highest and the lowest Domestic credit (% of GDP) of Tanzania?
Keep it short and to the point. 3.66. 